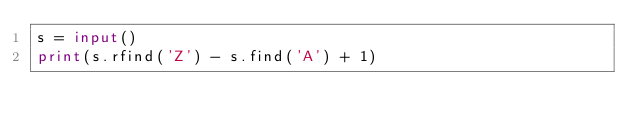Convert code to text. <code><loc_0><loc_0><loc_500><loc_500><_Python_>s = input()
print(s.rfind('Z') - s.find('A') + 1)</code> 